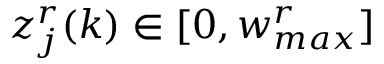Convert formula to latex. <formula><loc_0><loc_0><loc_500><loc_500>z _ { j } ^ { r } ( k ) \in [ 0 , w _ { \max } ^ { r } ]</formula> 